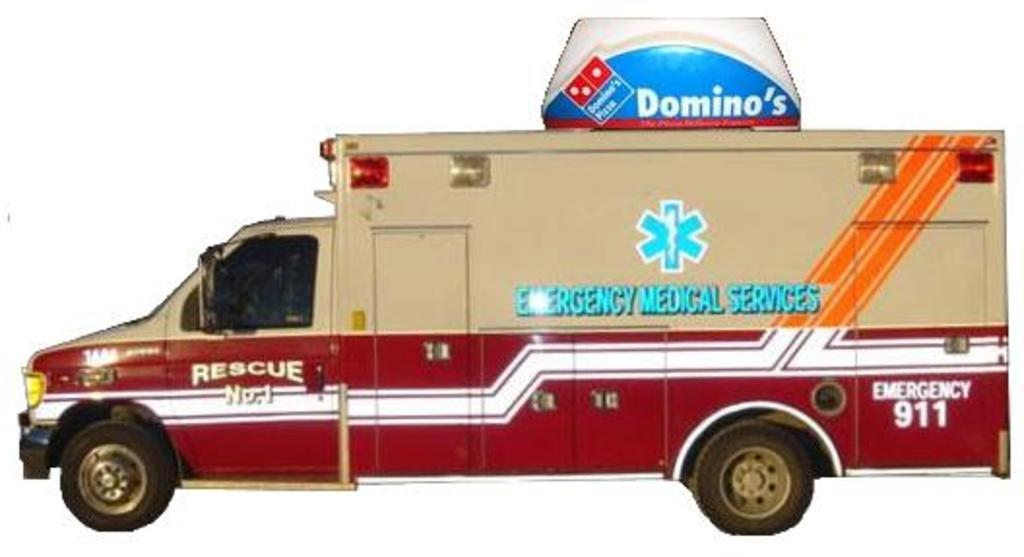What is the main subject of the image? There is a picture of a motor vehicle in the image. What type of plate is used to serve the meal in the image? There is no meal or plate present in the image; it features a picture of a motor vehicle. How much payment is required to use the carriage in the image? There is no carriage or payment mentioned in the image; it features a picture of a motor vehicle. 